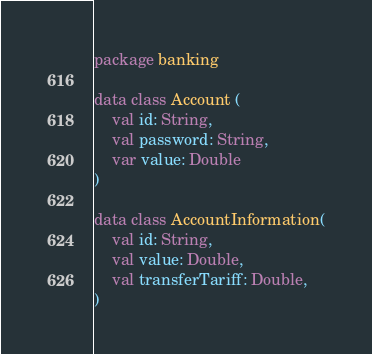<code> <loc_0><loc_0><loc_500><loc_500><_Kotlin_>package banking

data class Account (
    val id: String,
    val password: String,
    var value: Double
)

data class AccountInformation(
    val id: String,
    val value: Double,
    val transferTariff: Double,
)</code> 